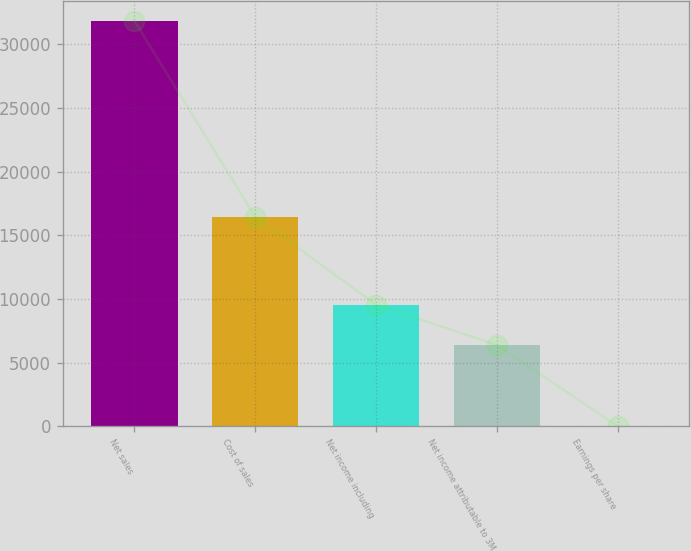<chart> <loc_0><loc_0><loc_500><loc_500><bar_chart><fcel>Net sales<fcel>Cost of sales<fcel>Net income including<fcel>Net income attributable to 3M<fcel>Earnings per share<nl><fcel>31821<fcel>16447<fcel>9551.54<fcel>6370.19<fcel>7.49<nl></chart> 